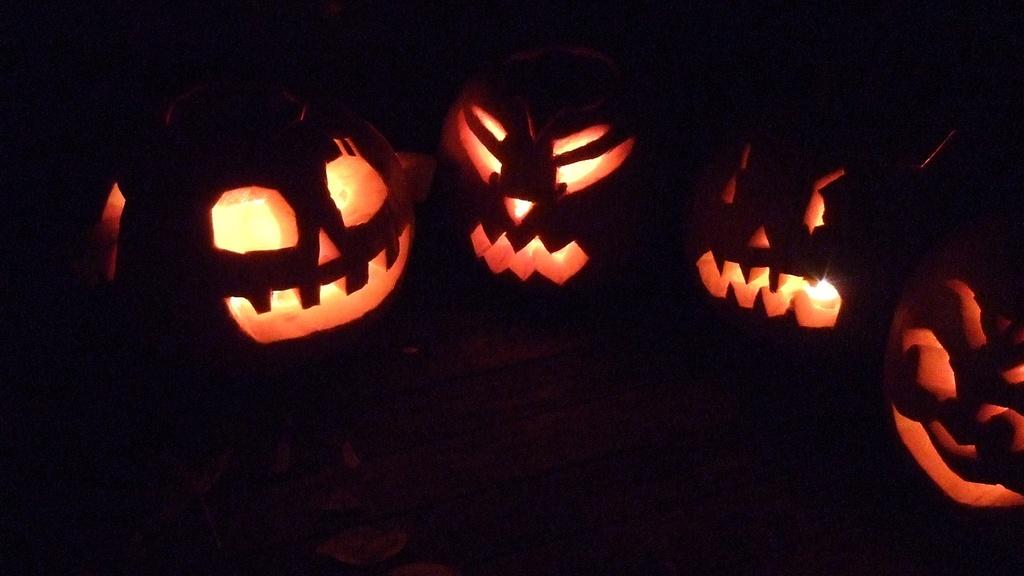What objects are present in the image? There are pumpkins in the image. What is unique about these pumpkins? The pumpkins have lights inside them. What can be inferred about the lighting conditions in the image? The background of the image is dark. What letter is being used to spell out a rule in the image? There is no letter or rule present in the image; it only features pumpkins with lights inside them. 